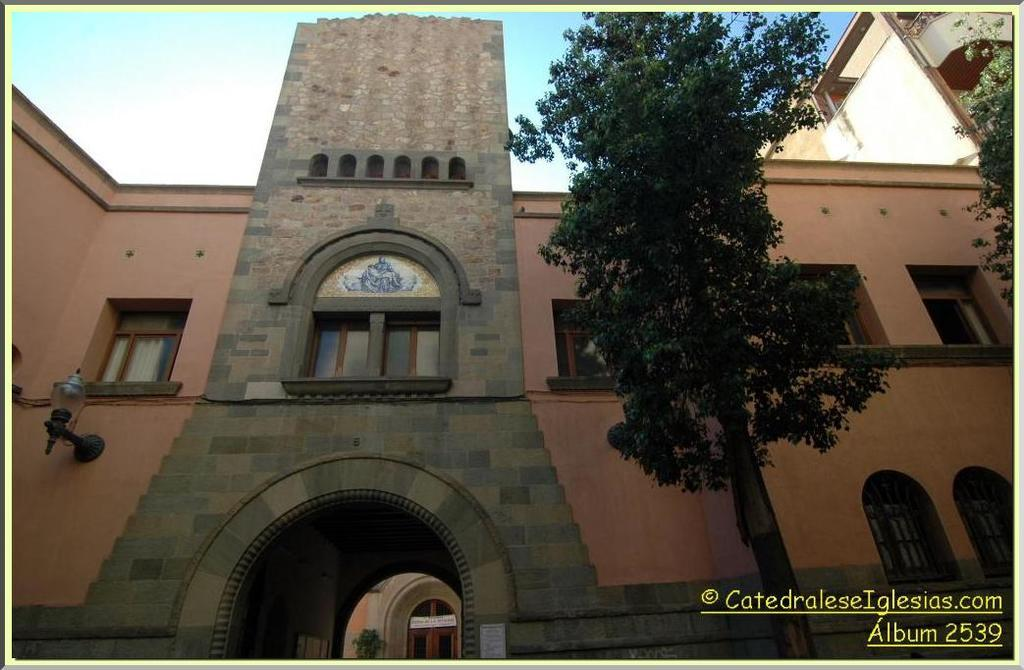What type of structures are located in the center of the image? There are houses and buildings in the center of the image. What type of vegetation can be seen in the image? There are trees in the image. What is visible at the top of the image? The sky is visible at the top of the image. What is written or displayed at the bottom of the image? There is text at the bottom of the image. What time of day is depicted in the image? The time of day cannot be determined from the image, as there are no specific indicators of day or night. How many quarters are visible in the image? There are no quarters present in the image. 